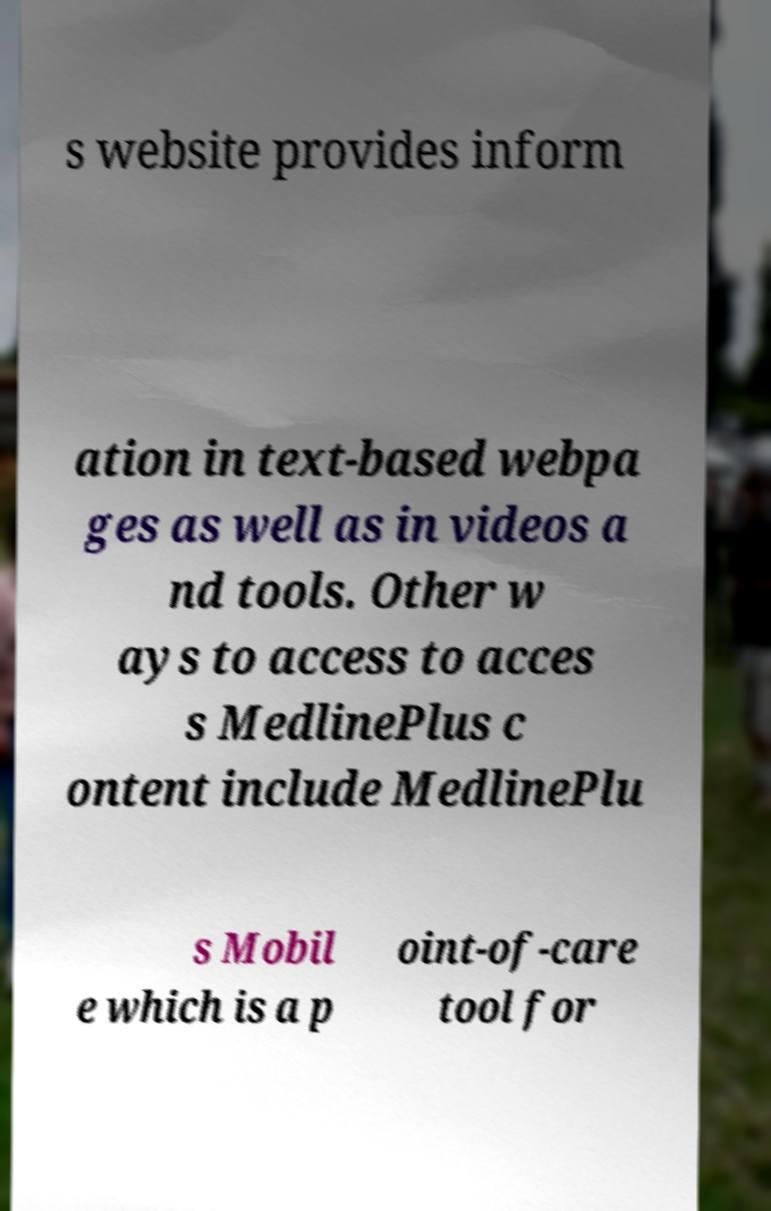Could you extract and type out the text from this image? s website provides inform ation in text-based webpa ges as well as in videos a nd tools. Other w ays to access to acces s MedlinePlus c ontent include MedlinePlu s Mobil e which is a p oint-of-care tool for 